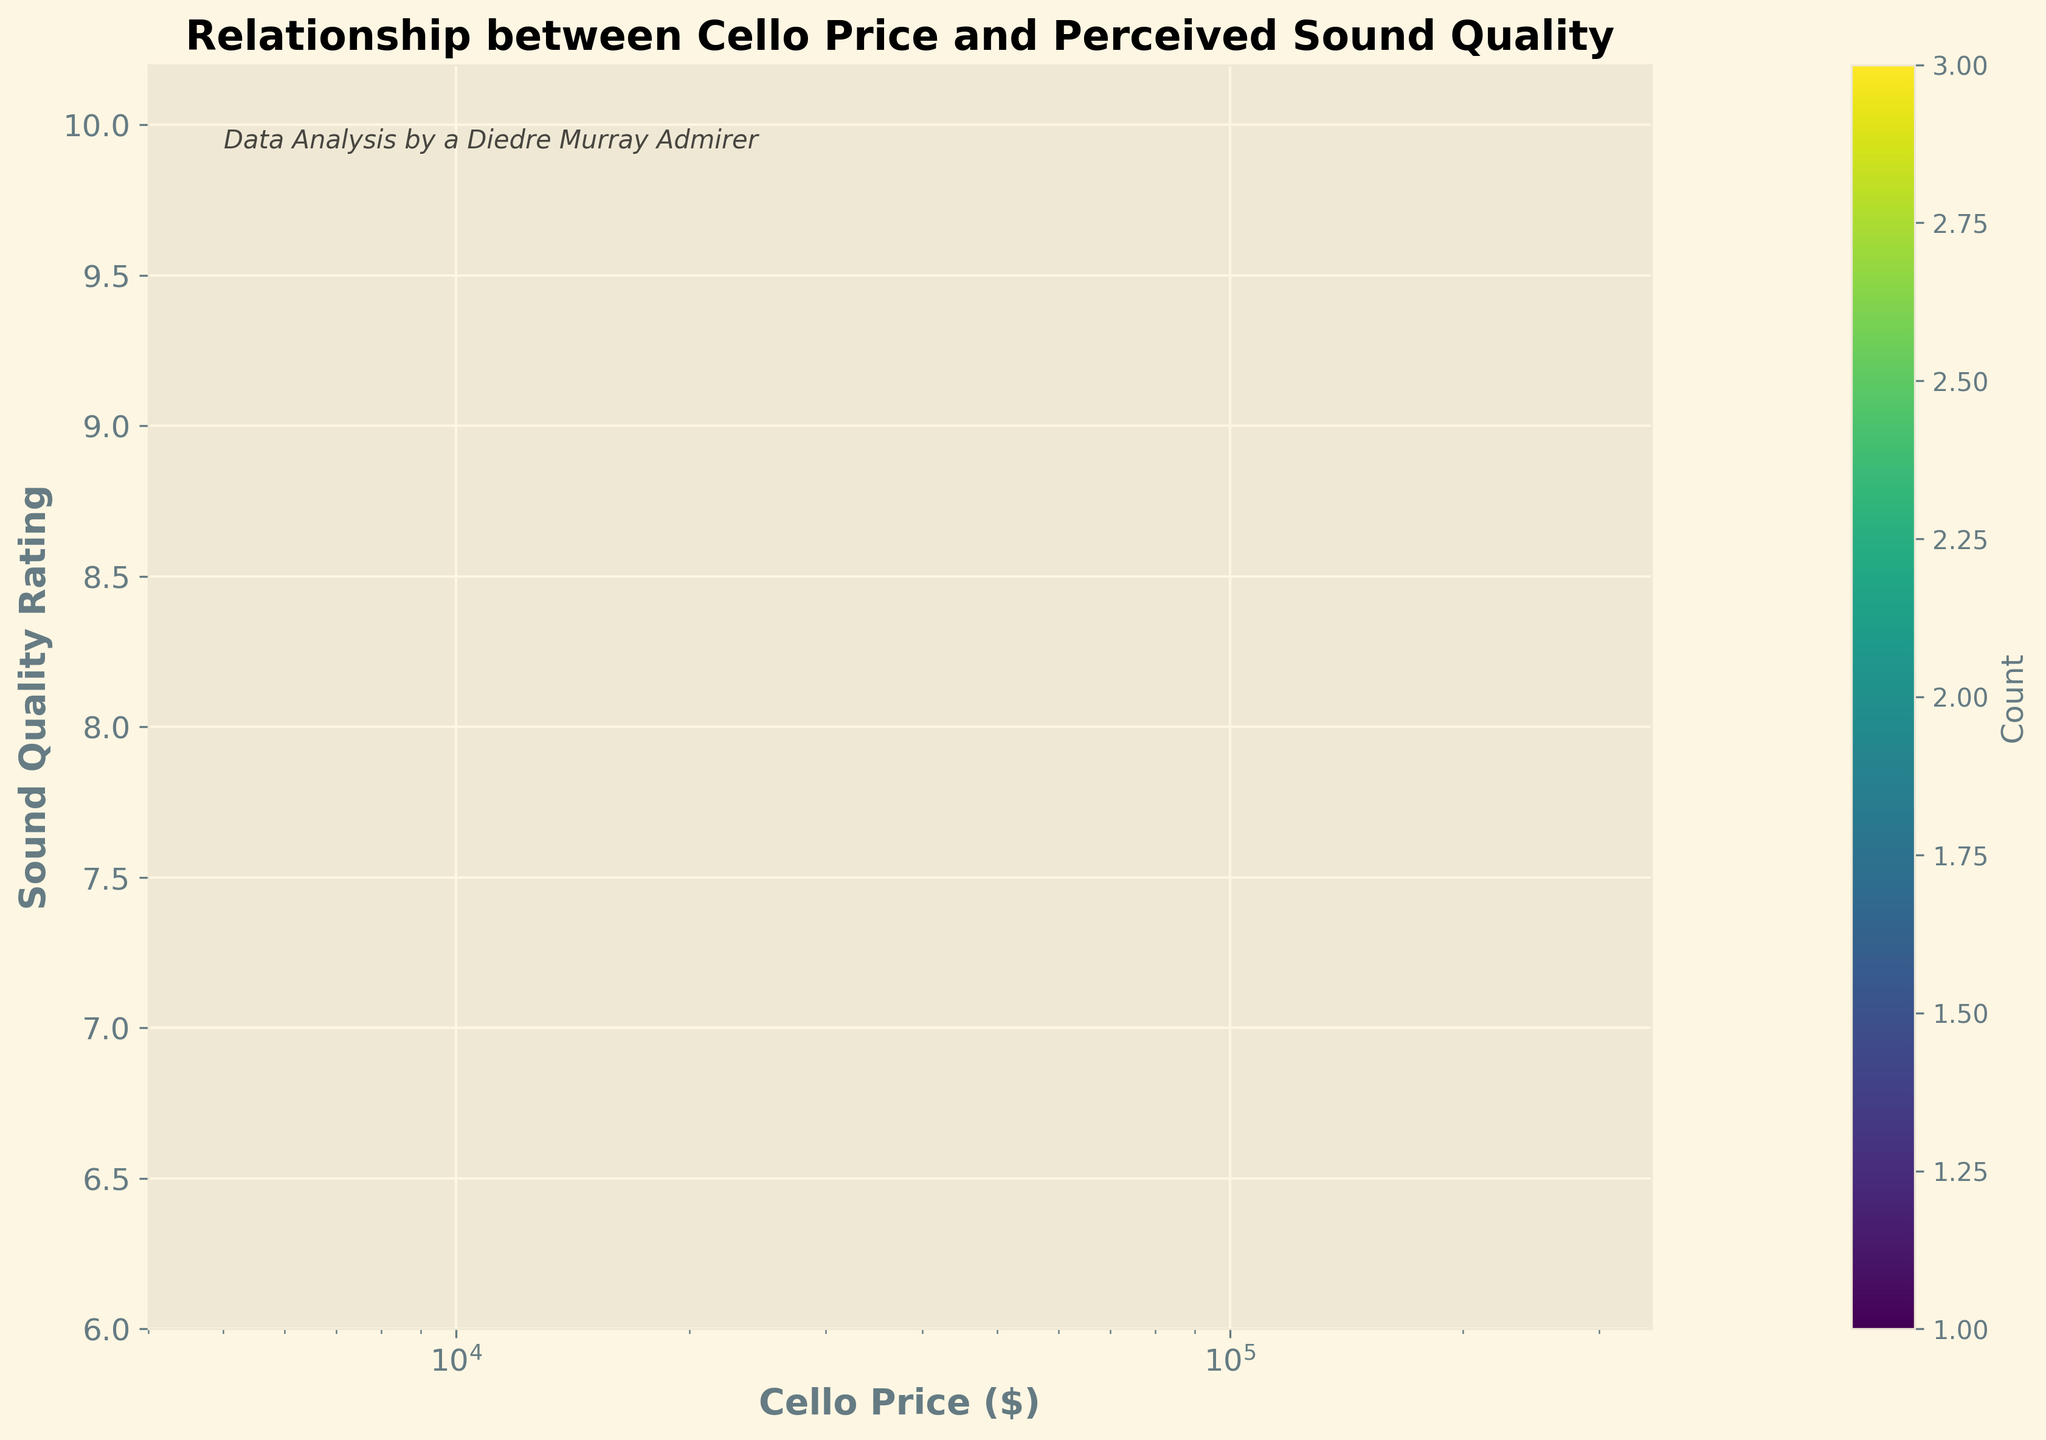What is the title of the figure? The title of the figure is displayed at the top and it reads "Relationship between Cello Price and Perceived Sound Quality".
Answer: Relationship between Cello Price and Perceived Sound Quality What is the color scheme of the hexbin plot? The color scheme used in the hexbin plot is a gradient of colors from the 'viridis' colormap, which typically ranges from purple to yellow.
Answer: viridis What information does the color bar convey? The color bar on the right side of the plot shows the count of data points within each hexbin cell. The different colors correspond to different counts.
Answer: Count of data points Which axis represents the cello price? The x-axis represents the cello price, as indicated by the label 'Cello Price ($)'.
Answer: x-axis What is the range of the cello prices displayed on the x-axis? The x-axis is logarithmic and ranges from approximately $4000 to $350000, as indicated by the axis labels and ticks.
Answer: $4000 to $350000 What is the highest sound quality rating observed? The highest sound quality rating observed on the y-axis is 10. This is shown at the top end of the y-axis labeled 'Sound Quality Rating (1-10)'.
Answer: 10 How does the sound quality rating change with increasing cello price? As the cello price increases, the sound quality rating generally increases. This can be seen by the trend of data points moving upwards as you move to the right on the plot.
Answer: Increases Is the relationship between cello price and sound quality linear? The relationship appears to be more exponential rather than linear, as shown by the logarithmic scale on the x-axis and the trend moving steeply upwards.
Answer: Exponential What price range shows the most concentration of data points? The most concentration of data points appears to be around the $20,000 to $100,000 price range, indicated by the denser hexbin cells in that region.
Answer: $20,000 to $100,000 How many data points likely exist at the highest price range? The color in the hexbin cells at the highest price range (close to $300,000) indicates a lower count of data points, likely 1 or 2, based on the color gradient.
Answer: 1 or 2 